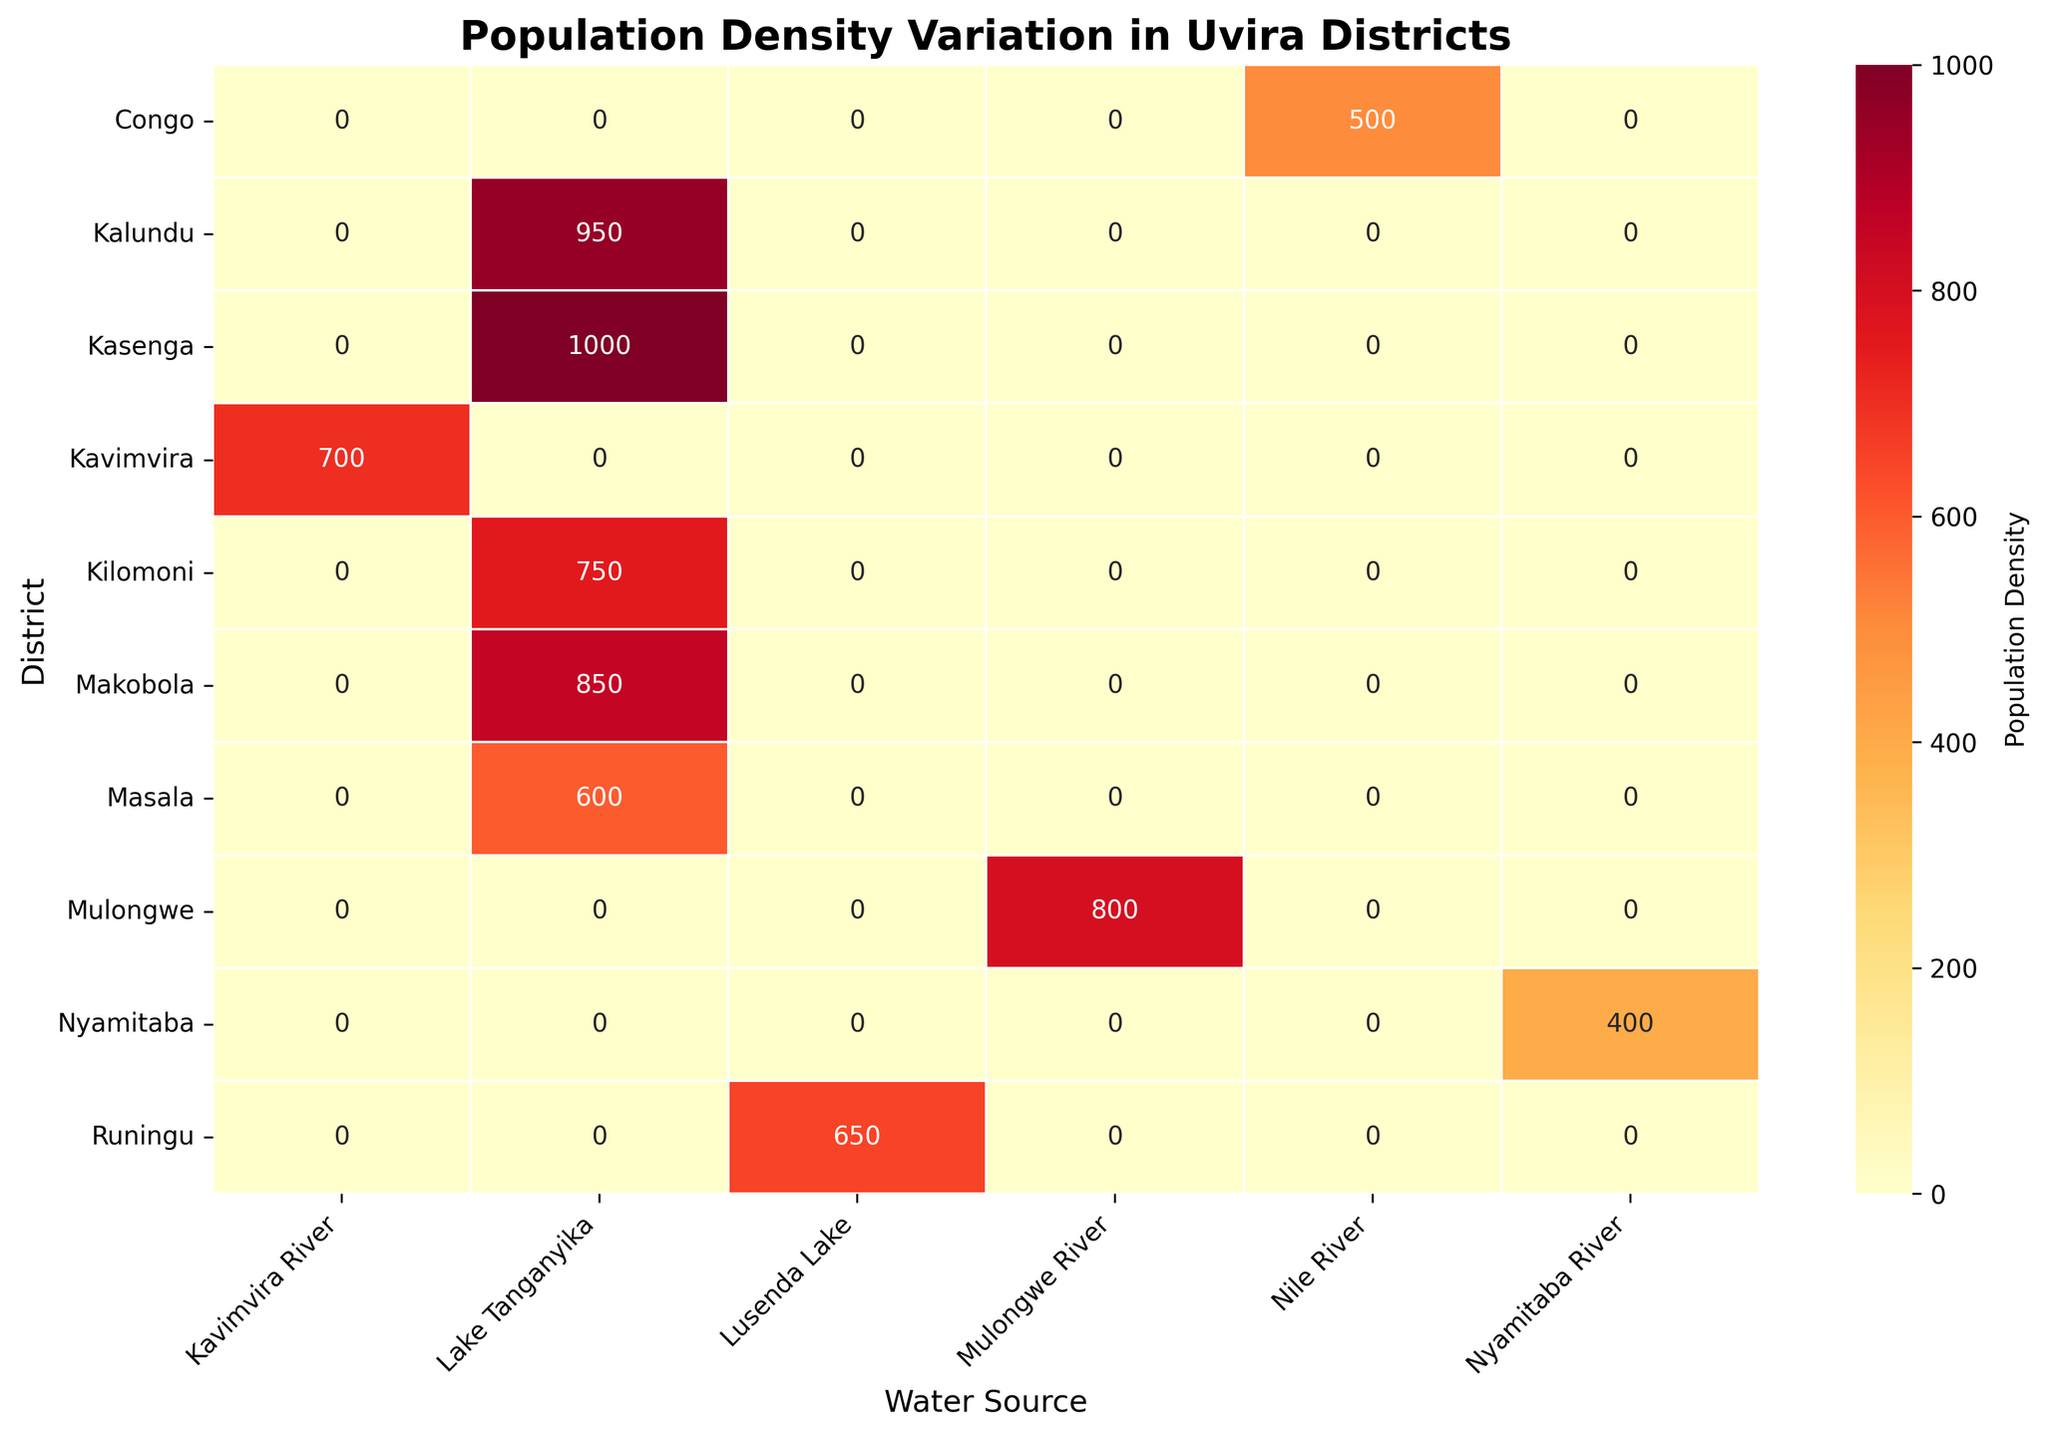What is the title of the heatmap? The title is written at the top of the heatmap and provides the main topic of the visualization.
Answer: Population Density Variation in Uvira Districts Which district has the highest population density? Look for the highest labeled number in the heatmap and find the corresponding district.
Answer: Kasenga What water source is associated with Makobola district? Identify the intersection at Makobola district's row in the heatmap and see which water source column it is under.
Answer: Lake Tanganyika What is the sum of the population densities of districts with Lake Tanganyika as their water source? Add up the population densities listed under the Lake Tanganyika column: 950 + 600 + 1000 + 850 + 750 = 4150.
Answer: 4150 How does the population density in Mulongwe district compare to that in Kavimvira district? Compare the two values found at Mulongwe and Kavimvira's intersections in the heatmap.
Answer: Mulongwe is higher What is the average population density for districts with a river as their water source rather than a lake? Sum the population densities of districts with river water sources (Congo 500 + Mulongwe 800 + Kavimvira 700 + Nyamitaba 400), then divide by the number of districts (4). Average: (500 + 800 + 700 + 400) / 4 = 600.
Answer: 600 Which water source has the most districts with a population density greater than 800? Check each water source's column to count the number of districts with values above 800. Lake Tanganyika has 4 (Kalundu, Kasenga, Makobola, Kilomoni).
Answer: Lake Tanganyika How many districts have a population density between 600 and 900? Count the number of heatmap cells with values within this range. The districts are: Kalundu 950, Mulongwe 800, Makobola 850, Kilomoni 750, Runingu 650, Masala 600, Kavimvira 700. Total is 7.
Answer: 7 Which district has the lowest population density and its associated water source? Look for the lowest labeled number in the heatmap and find the corresponding district and water source.
Answer: Nyamitaba, Nyamitaba River What is the population density difference between the district with the highest density and that with the second-highest density? Find the highest (Kasenga 1000) and second-highest (Kalundu 950), then subtract the second-highest from the highest: 1000 - 950 = 50.
Answer: 50 